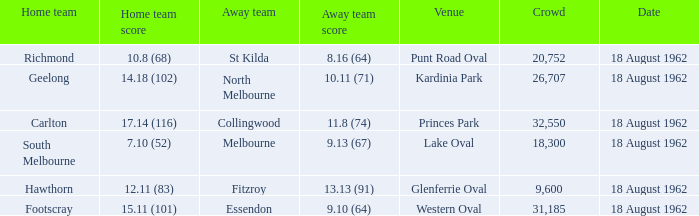8 (68)? St Kilda. 